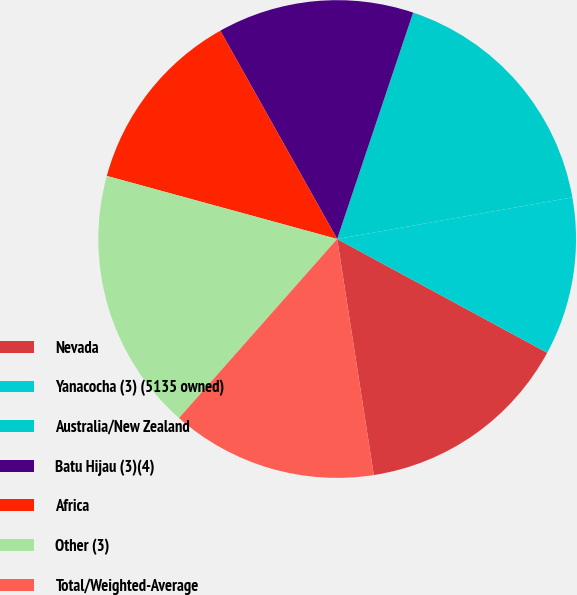<chart> <loc_0><loc_0><loc_500><loc_500><pie_chart><fcel>Nevada<fcel>Yanacocha (3) (5135 owned)<fcel>Australia/New Zealand<fcel>Batu Hijau (3)(4)<fcel>Africa<fcel>Other (3)<fcel>Total/Weighted-Average<nl><fcel>14.65%<fcel>10.69%<fcel>17.06%<fcel>13.29%<fcel>12.61%<fcel>17.74%<fcel>13.97%<nl></chart> 